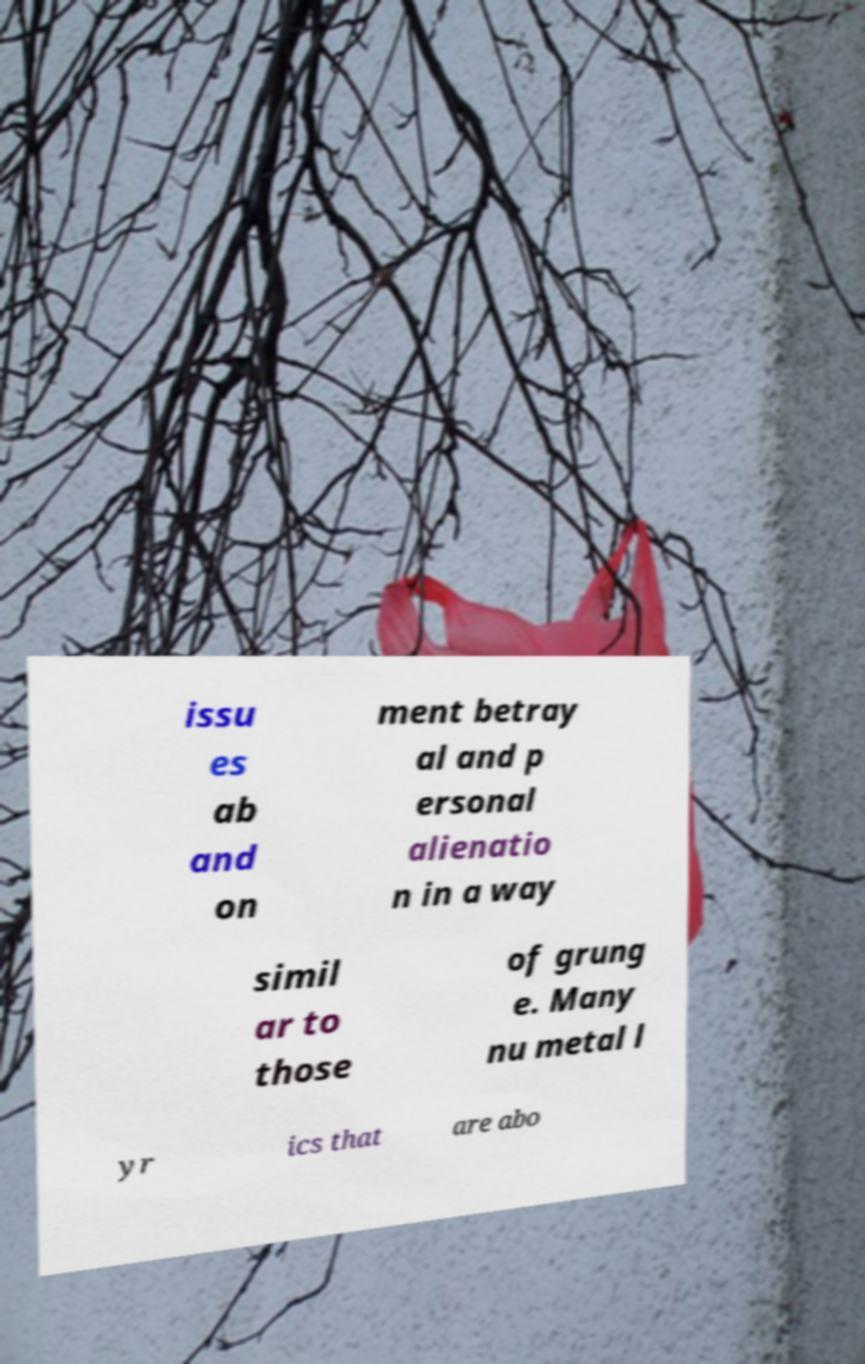For documentation purposes, I need the text within this image transcribed. Could you provide that? issu es ab and on ment betray al and p ersonal alienatio n in a way simil ar to those of grung e. Many nu metal l yr ics that are abo 